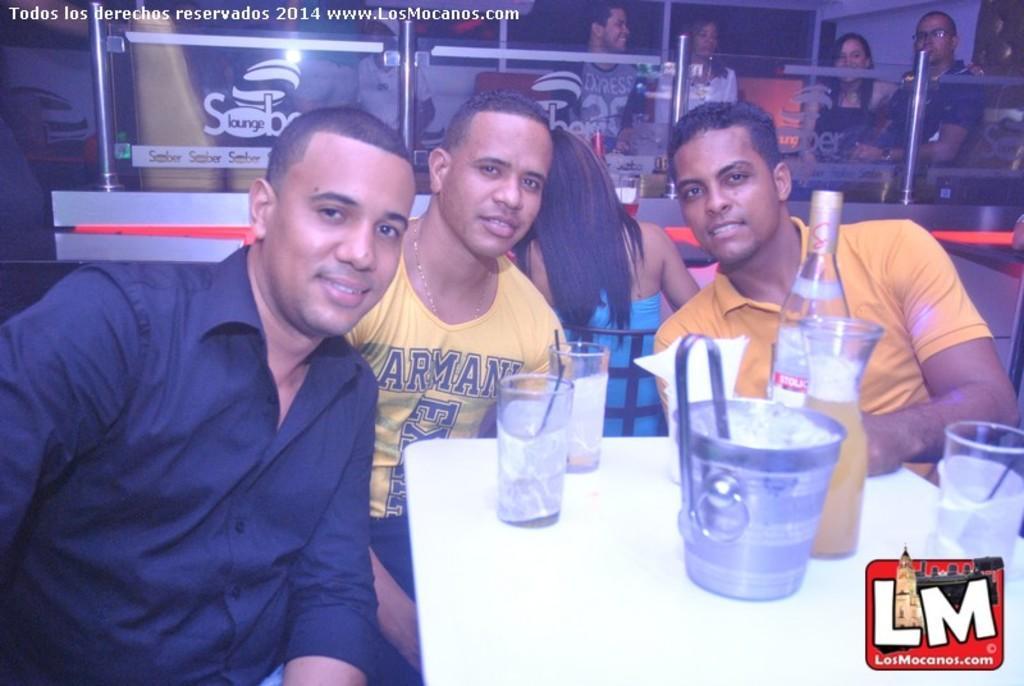How would you summarize this image in a sentence or two? In this picture, we see four people sitting on the chairs. Out of them, three are posing for the photo. In front of them, we see a table on which glasses and glass bottle are placed. Behind that, we see a glass door. Behind that, we see people sitting on the chairs. This picture is clicked in the restaurant. 